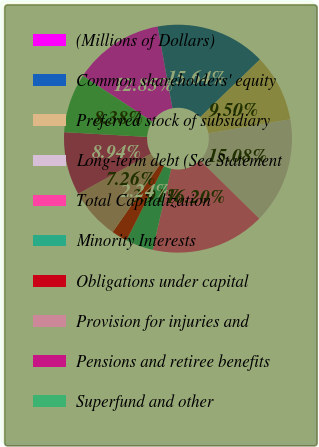Convert chart. <chart><loc_0><loc_0><loc_500><loc_500><pie_chart><fcel>(Millions of Dollars)<fcel>Common shareholders' equity<fcel>Preferred stock of subsidiary<fcel>Long-term debt (See Statement<fcel>Total Capitalization<fcel>Minority Interests<fcel>Obligations under capital<fcel>Provision for injuries and<fcel>Pensions and retiree benefits<fcel>Superfund and other<nl><fcel>12.85%<fcel>15.64%<fcel>9.5%<fcel>15.08%<fcel>16.2%<fcel>3.91%<fcel>2.24%<fcel>7.26%<fcel>8.94%<fcel>8.38%<nl></chart> 